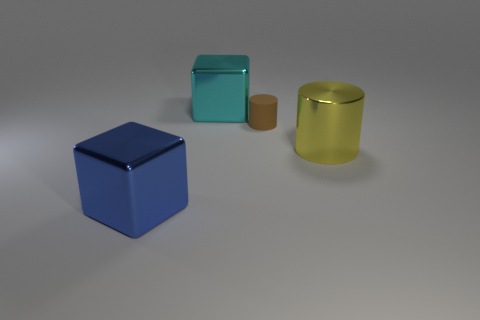What is the color of the other shiny object that is the same shape as the tiny brown object?
Offer a very short reply. Yellow. The big object that is in front of the brown matte object and on the left side of the tiny brown matte cylinder is made of what material?
Offer a terse response. Metal. Does the metallic cube left of the cyan metal thing have the same size as the yellow cylinder?
Offer a terse response. Yes. What material is the big yellow cylinder?
Ensure brevity in your answer.  Metal. What is the color of the big shiny thing that is behind the tiny cylinder?
Your answer should be very brief. Cyan. What number of big objects are metallic things or purple cubes?
Your answer should be very brief. 3. Is the color of the large metallic block that is behind the tiny thing the same as the big thing that is right of the small thing?
Make the answer very short. No. What number of other things are the same color as the rubber cylinder?
Ensure brevity in your answer.  0. What number of yellow objects are tiny rubber things or blocks?
Give a very brief answer. 0. There is a brown thing; is its shape the same as the object that is on the right side of the rubber cylinder?
Make the answer very short. Yes. 